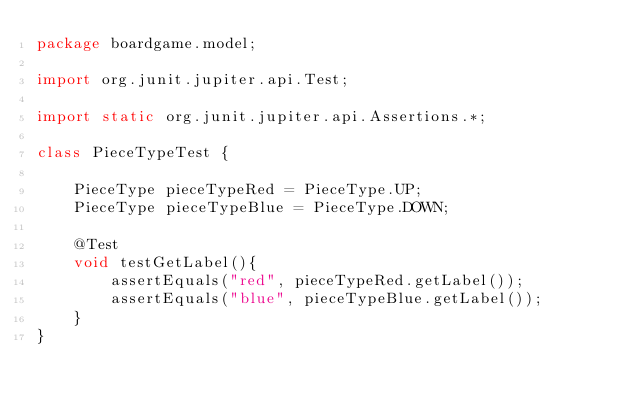Convert code to text. <code><loc_0><loc_0><loc_500><loc_500><_Java_>package boardgame.model;

import org.junit.jupiter.api.Test;

import static org.junit.jupiter.api.Assertions.*;

class PieceTypeTest {

    PieceType pieceTypeRed = PieceType.UP;
    PieceType pieceTypeBlue = PieceType.DOWN;

    @Test
    void testGetLabel(){
        assertEquals("red", pieceTypeRed.getLabel());
        assertEquals("blue", pieceTypeBlue.getLabel());
    }
}</code> 